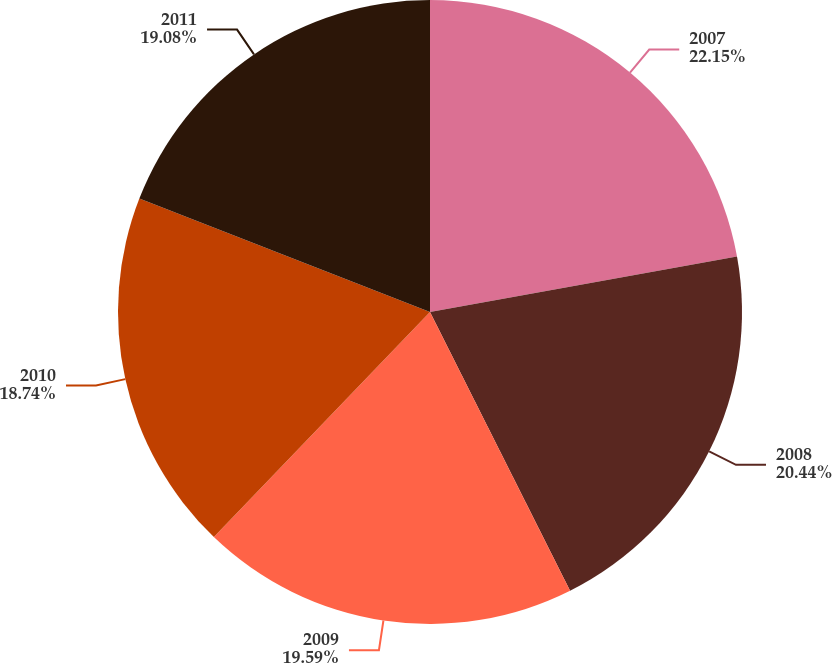Convert chart to OTSL. <chart><loc_0><loc_0><loc_500><loc_500><pie_chart><fcel>2007<fcel>2008<fcel>2009<fcel>2010<fcel>2011<nl><fcel>22.15%<fcel>20.44%<fcel>19.59%<fcel>18.74%<fcel>19.08%<nl></chart> 